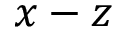<formula> <loc_0><loc_0><loc_500><loc_500>x - z</formula> 